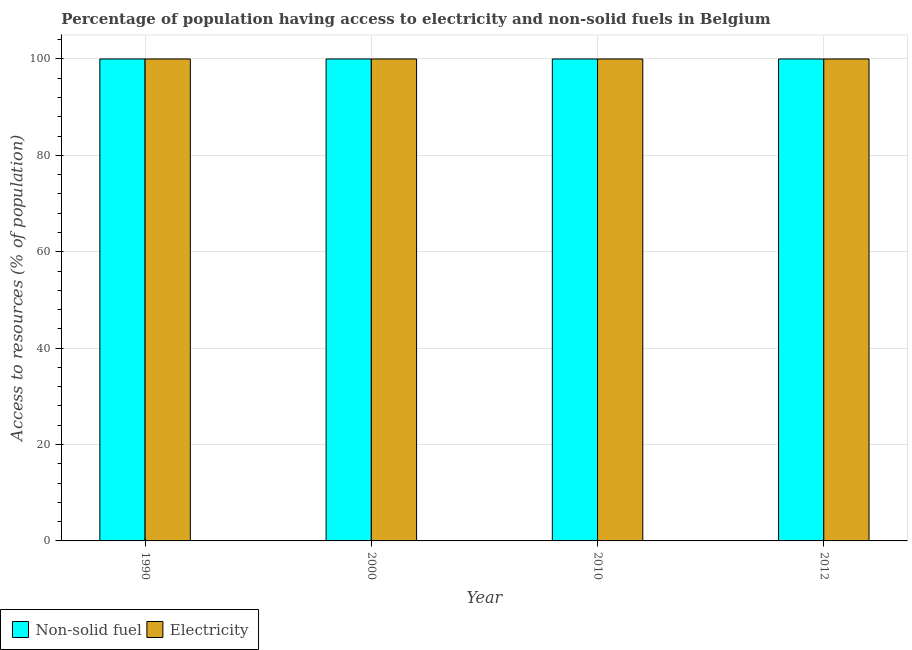Are the number of bars per tick equal to the number of legend labels?
Your answer should be compact. Yes. How many bars are there on the 4th tick from the right?
Offer a very short reply. 2. In how many cases, is the number of bars for a given year not equal to the number of legend labels?
Provide a succinct answer. 0. What is the percentage of population having access to non-solid fuel in 1990?
Keep it short and to the point. 100. Across all years, what is the maximum percentage of population having access to non-solid fuel?
Your answer should be very brief. 100. Across all years, what is the minimum percentage of population having access to electricity?
Offer a very short reply. 100. In which year was the percentage of population having access to non-solid fuel maximum?
Give a very brief answer. 1990. In which year was the percentage of population having access to electricity minimum?
Provide a short and direct response. 1990. What is the total percentage of population having access to non-solid fuel in the graph?
Provide a short and direct response. 400. What is the difference between the percentage of population having access to electricity in 1990 and that in 2000?
Your response must be concise. 0. In the year 2012, what is the difference between the percentage of population having access to electricity and percentage of population having access to non-solid fuel?
Give a very brief answer. 0. In how many years, is the percentage of population having access to electricity greater than 88 %?
Your response must be concise. 4. Is the percentage of population having access to non-solid fuel in 2010 less than that in 2012?
Offer a very short reply. No. Is the difference between the percentage of population having access to electricity in 1990 and 2012 greater than the difference between the percentage of population having access to non-solid fuel in 1990 and 2012?
Your answer should be very brief. No. Is the sum of the percentage of population having access to electricity in 2000 and 2010 greater than the maximum percentage of population having access to non-solid fuel across all years?
Give a very brief answer. Yes. What does the 2nd bar from the left in 2010 represents?
Your answer should be compact. Electricity. What does the 1st bar from the right in 2010 represents?
Your response must be concise. Electricity. How many years are there in the graph?
Your answer should be compact. 4. Does the graph contain grids?
Keep it short and to the point. Yes. What is the title of the graph?
Give a very brief answer. Percentage of population having access to electricity and non-solid fuels in Belgium. Does "Death rate" appear as one of the legend labels in the graph?
Ensure brevity in your answer.  No. What is the label or title of the Y-axis?
Your response must be concise. Access to resources (% of population). What is the Access to resources (% of population) of Electricity in 1990?
Ensure brevity in your answer.  100. What is the Access to resources (% of population) in Non-solid fuel in 2000?
Your response must be concise. 100. What is the Access to resources (% of population) in Non-solid fuel in 2010?
Keep it short and to the point. 100. What is the Access to resources (% of population) of Non-solid fuel in 2012?
Provide a succinct answer. 100. What is the Access to resources (% of population) in Electricity in 2012?
Make the answer very short. 100. Across all years, what is the maximum Access to resources (% of population) in Non-solid fuel?
Your answer should be very brief. 100. Across all years, what is the minimum Access to resources (% of population) of Non-solid fuel?
Your answer should be compact. 100. What is the difference between the Access to resources (% of population) of Electricity in 1990 and that in 2000?
Your answer should be compact. 0. What is the difference between the Access to resources (% of population) of Electricity in 1990 and that in 2010?
Your response must be concise. 0. What is the difference between the Access to resources (% of population) in Electricity in 2000 and that in 2010?
Your answer should be very brief. 0. What is the difference between the Access to resources (% of population) of Electricity in 2000 and that in 2012?
Your answer should be very brief. 0. What is the difference between the Access to resources (% of population) of Non-solid fuel in 1990 and the Access to resources (% of population) of Electricity in 2000?
Provide a succinct answer. 0. What is the difference between the Access to resources (% of population) in Non-solid fuel in 1990 and the Access to resources (% of population) in Electricity in 2012?
Keep it short and to the point. 0. What is the difference between the Access to resources (% of population) of Non-solid fuel in 2000 and the Access to resources (% of population) of Electricity in 2010?
Keep it short and to the point. 0. What is the difference between the Access to resources (% of population) of Non-solid fuel in 2000 and the Access to resources (% of population) of Electricity in 2012?
Offer a terse response. 0. What is the difference between the Access to resources (% of population) of Non-solid fuel in 2010 and the Access to resources (% of population) of Electricity in 2012?
Your response must be concise. 0. What is the average Access to resources (% of population) in Non-solid fuel per year?
Keep it short and to the point. 100. What is the average Access to resources (% of population) of Electricity per year?
Provide a succinct answer. 100. In the year 2010, what is the difference between the Access to resources (% of population) in Non-solid fuel and Access to resources (% of population) in Electricity?
Your answer should be compact. 0. In the year 2012, what is the difference between the Access to resources (% of population) in Non-solid fuel and Access to resources (% of population) in Electricity?
Make the answer very short. 0. What is the ratio of the Access to resources (% of population) in Non-solid fuel in 1990 to that in 2000?
Give a very brief answer. 1. What is the ratio of the Access to resources (% of population) of Electricity in 1990 to that in 2000?
Offer a very short reply. 1. What is the ratio of the Access to resources (% of population) in Non-solid fuel in 1990 to that in 2010?
Keep it short and to the point. 1. What is the ratio of the Access to resources (% of population) of Electricity in 1990 to that in 2010?
Make the answer very short. 1. What is the ratio of the Access to resources (% of population) of Non-solid fuel in 1990 to that in 2012?
Make the answer very short. 1. What is the ratio of the Access to resources (% of population) of Electricity in 1990 to that in 2012?
Your response must be concise. 1. What is the ratio of the Access to resources (% of population) of Non-solid fuel in 2000 to that in 2010?
Offer a very short reply. 1. What is the ratio of the Access to resources (% of population) in Electricity in 2000 to that in 2010?
Provide a succinct answer. 1. What is the ratio of the Access to resources (% of population) of Non-solid fuel in 2000 to that in 2012?
Make the answer very short. 1. What is the ratio of the Access to resources (% of population) of Electricity in 2010 to that in 2012?
Keep it short and to the point. 1. What is the difference between the highest and the second highest Access to resources (% of population) of Electricity?
Keep it short and to the point. 0. What is the difference between the highest and the lowest Access to resources (% of population) of Electricity?
Keep it short and to the point. 0. 